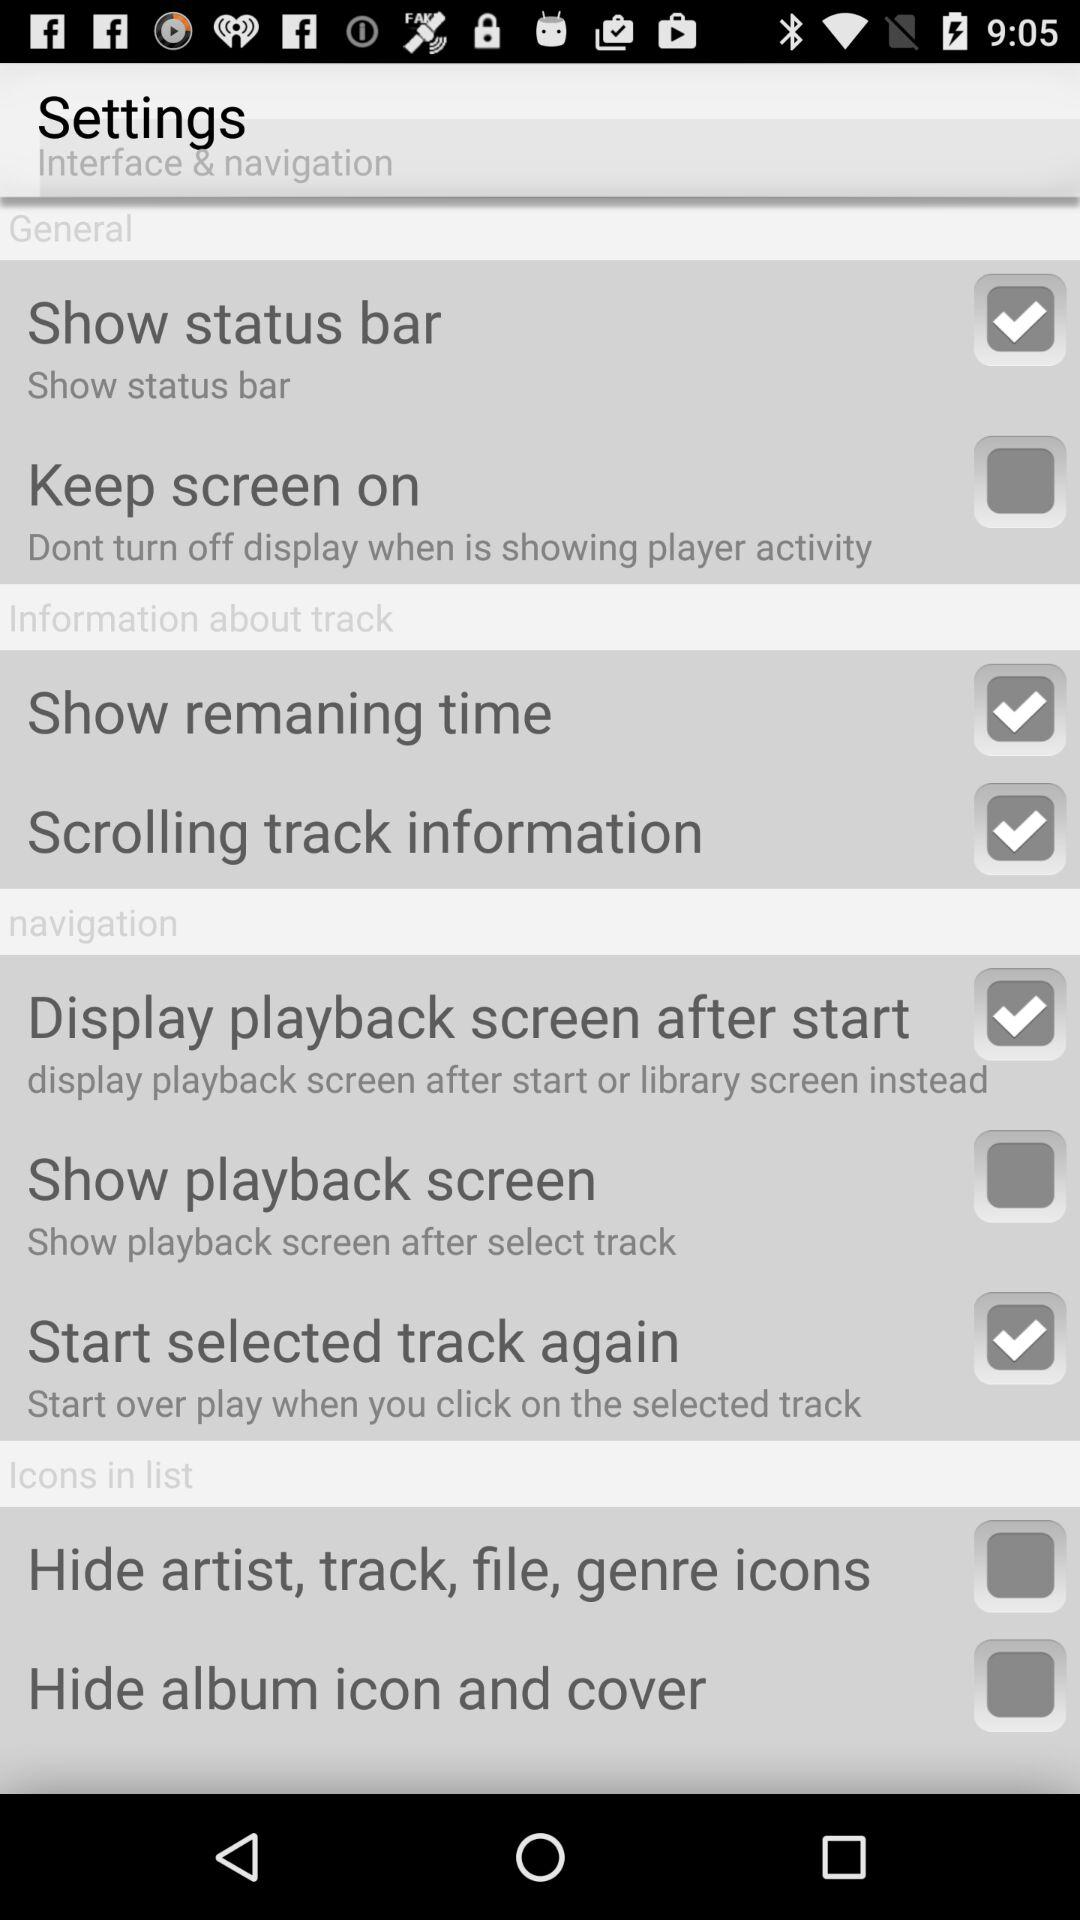What is the status of the "Show remaning time"? The status is "on". 